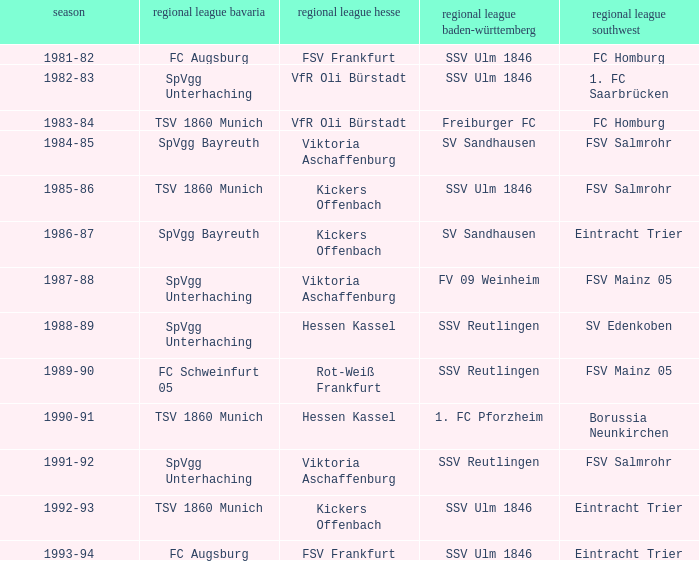Which Oberliga Südwest has an Oberliga Bayern of fc schweinfurt 05? FSV Mainz 05. 